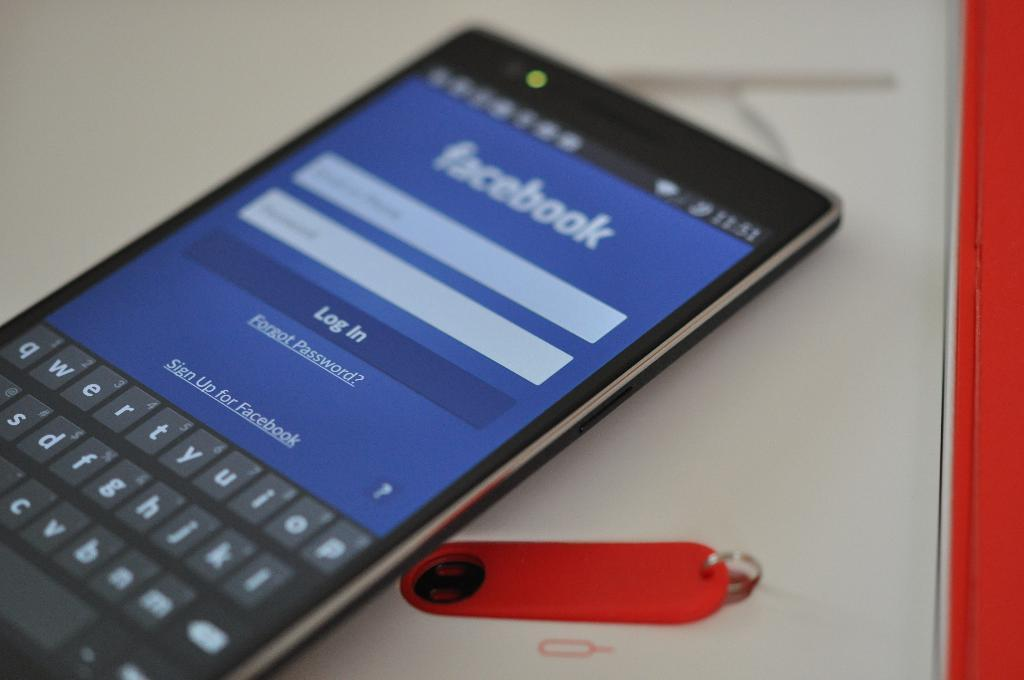What electronic device is present in the image? There is a cell phone in the image. What is displayed on the cell phone's screen? There is text visible on the cell phone's screen. What type of object is located at the bottom of the image? There appears to be a book at the bottom of the image. What is attached to the book in the image? There is a paper clip on the book. What type of leaf is used as a whip in the image? There is no leaf or whip present in the image. 